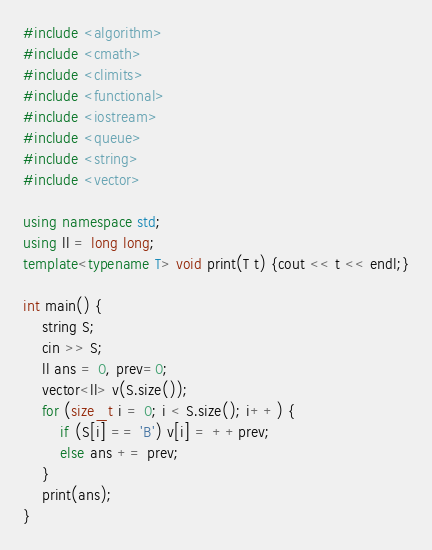Convert code to text. <code><loc_0><loc_0><loc_500><loc_500><_C++_>#include <algorithm>
#include <cmath>
#include <climits>
#include <functional>
#include <iostream>
#include <queue>
#include <string>
#include <vector>

using namespace std;
using ll = long long;
template<typename T> void print(T t) {cout << t << endl;}

int main() {
	string S; 
	cin >> S;
	ll ans = 0, prev=0;
	vector<ll> v(S.size());
	for (size_t i = 0; i < S.size(); i++) {
		if (S[i] == 'B') v[i] = ++prev;
		else ans += prev;
	}
	print(ans);
}</code> 